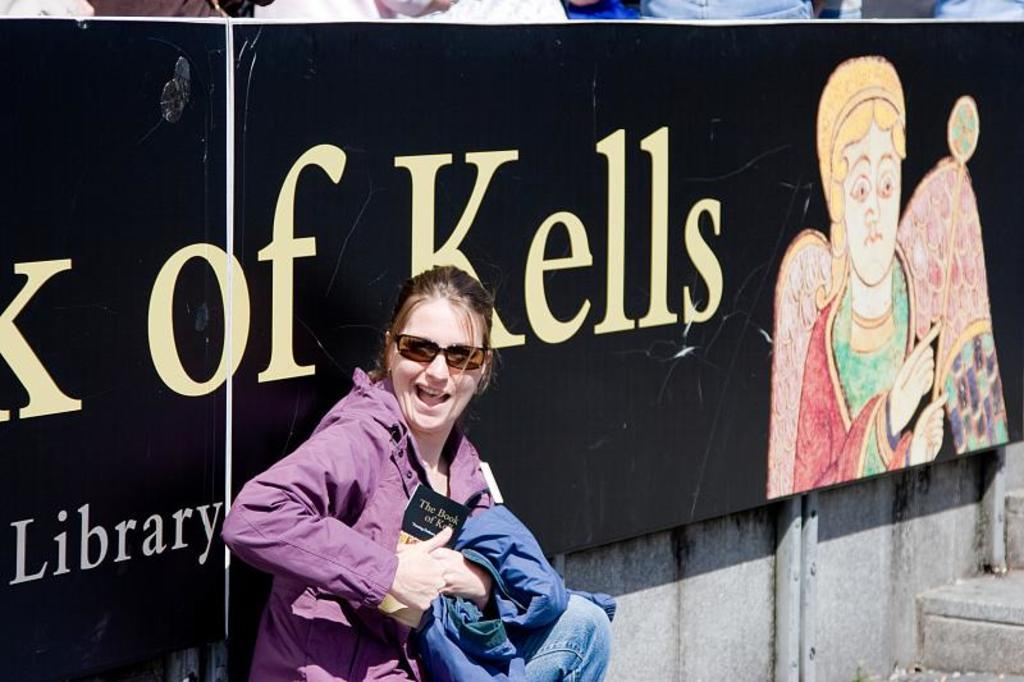Who is present in the image? There is a woman in the image. What is the woman doing in the image? The woman is smiling in the image. What objects is the woman holding? The woman is holding a jacket and a book in the image. What can be seen in the background of the image? There is a board in the background of the image. What type of magic is the woman performing on the baby in the image? There is no baby present in the image, and the woman is not performing any magic. 